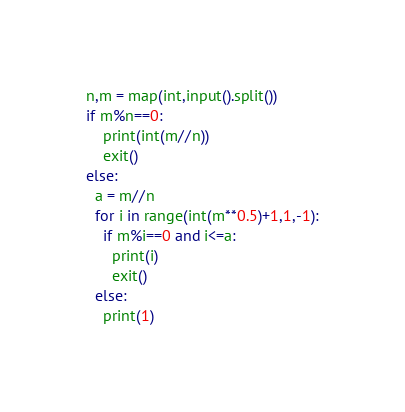Convert code to text. <code><loc_0><loc_0><loc_500><loc_500><_Python_>n,m = map(int,input().split())
if m%n==0:
    print(int(m//n))
    exit()
else:
  a = m//n
  for i in range(int(m**0.5)+1,1,-1):
    if m%i==0 and i<=a:
      print(i)
      exit()
  else:
    print(1)</code> 